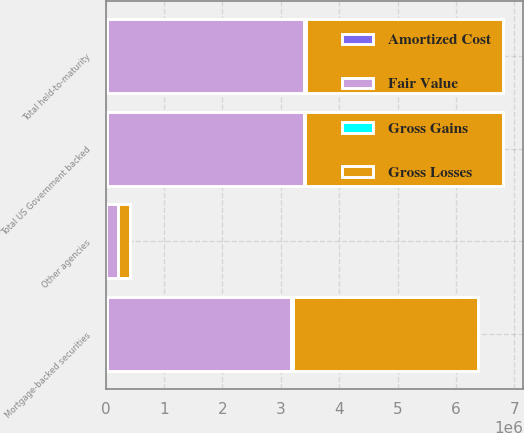Convert chart. <chart><loc_0><loc_0><loc_500><loc_500><stacked_bar_chart><ecel><fcel>Mortgage-backed securities<fcel>Other agencies<fcel>Total US Government backed<fcel>Total held-to-maturity<nl><fcel>Fair Value<fcel>3.16136e+06<fcel>210563<fcel>3.37192e+06<fcel>3.3799e+06<nl><fcel>Gross Gains<fcel>24832<fcel>1251<fcel>26083<fcel>26083<nl><fcel>Amortized Cost<fcel>21736<fcel>1150<fcel>22886<fcel>23273<nl><fcel>Gross Losses<fcel>3.16446e+06<fcel>210664<fcel>3.37512e+06<fcel>3.38272e+06<nl></chart> 